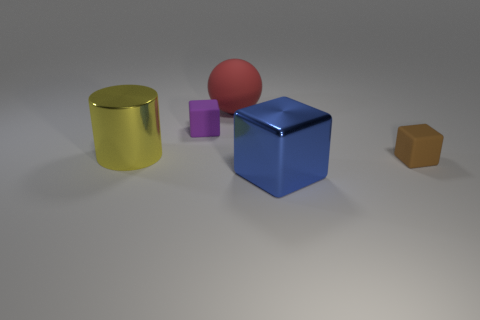There is a tiny thing that is to the right of the shiny block; does it have the same shape as the yellow shiny object that is in front of the small purple block?
Provide a succinct answer. No. How many blocks are either purple matte things or blue shiny objects?
Your answer should be very brief. 2. Are there fewer big yellow metallic cylinders that are in front of the large cylinder than red rubber balls?
Your answer should be very brief. Yes. What number of other things are there of the same material as the blue thing
Ensure brevity in your answer.  1. Does the brown object have the same size as the red rubber object?
Make the answer very short. No. How many things are either things behind the large yellow object or tiny matte things?
Make the answer very short. 3. What material is the tiny brown thing that is in front of the large metal object behind the blue metal cube?
Offer a very short reply. Rubber. Are there any other tiny matte objects that have the same shape as the tiny brown thing?
Your answer should be compact. Yes. There is a red matte thing; does it have the same size as the matte cube to the left of the large rubber sphere?
Your response must be concise. No. What number of objects are either blocks that are to the right of the blue shiny thing or big blue blocks on the right side of the tiny purple matte cube?
Your answer should be compact. 2. 